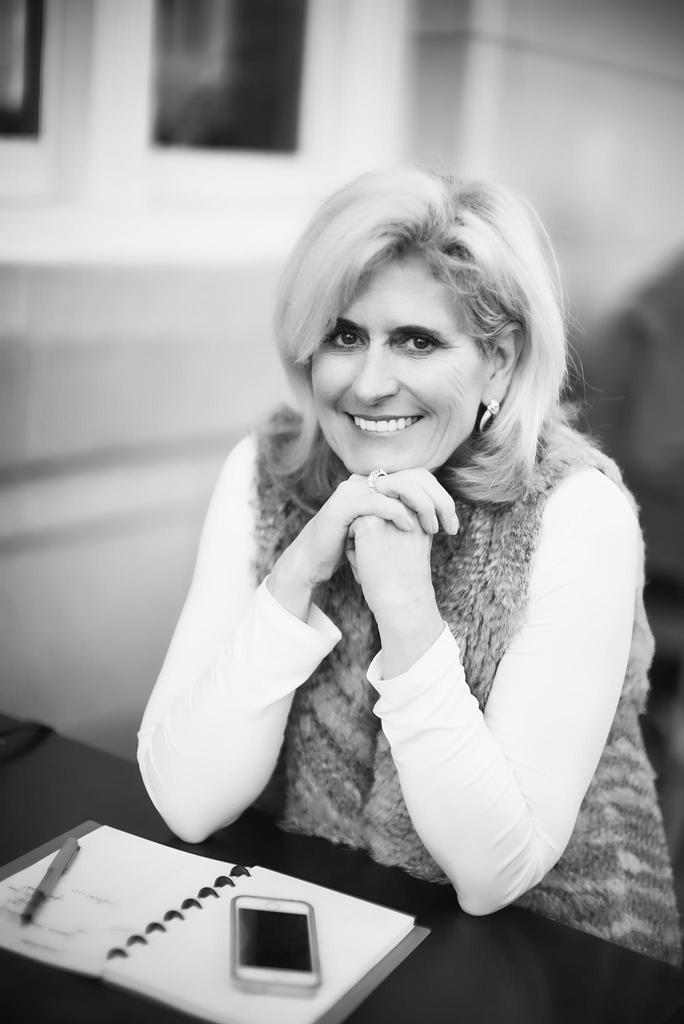Who is present in the image? There is a woman in the image. What is the woman doing? The woman is smiling. What is the woman sitting on? The woman is sitting on a seating stool. What is in front of the woman? There is a table in front of the woman. What objects are on the table? There is a mobile, a pen, and a book on the table. What type of cave can be seen in the background of the image? There is no cave present in the image; it features a woman sitting on a stool with a table in front of her. 